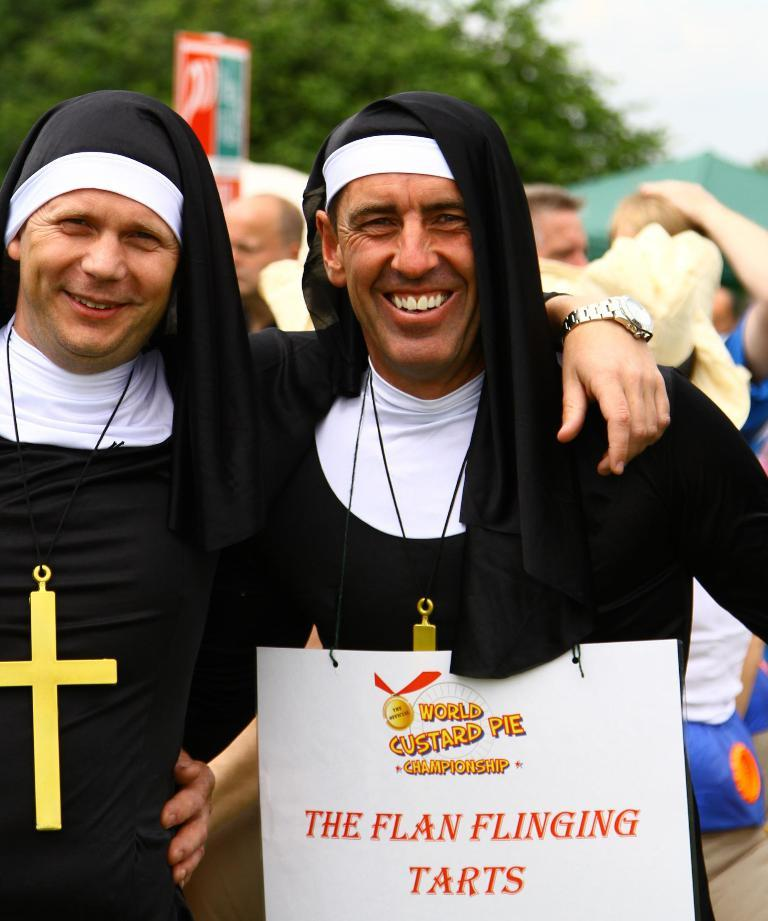How many people are present in the image? There are two persons standing in the image. What is the facial expression of the two persons? The two persons are smiling. What can be seen in the background of the image? There is a group of people and trees in the background of the image. What is visible in the sky in the image? The sky is visible in the background of the image. What type of punishment is being handed out to the person riding the bike in the image? There is no person riding a bike in the image, nor is there any indication of punishment. What type of industry is depicted in the image? There is no industry depicted in the image; it features two persons standing and a background with trees and a group of people. 